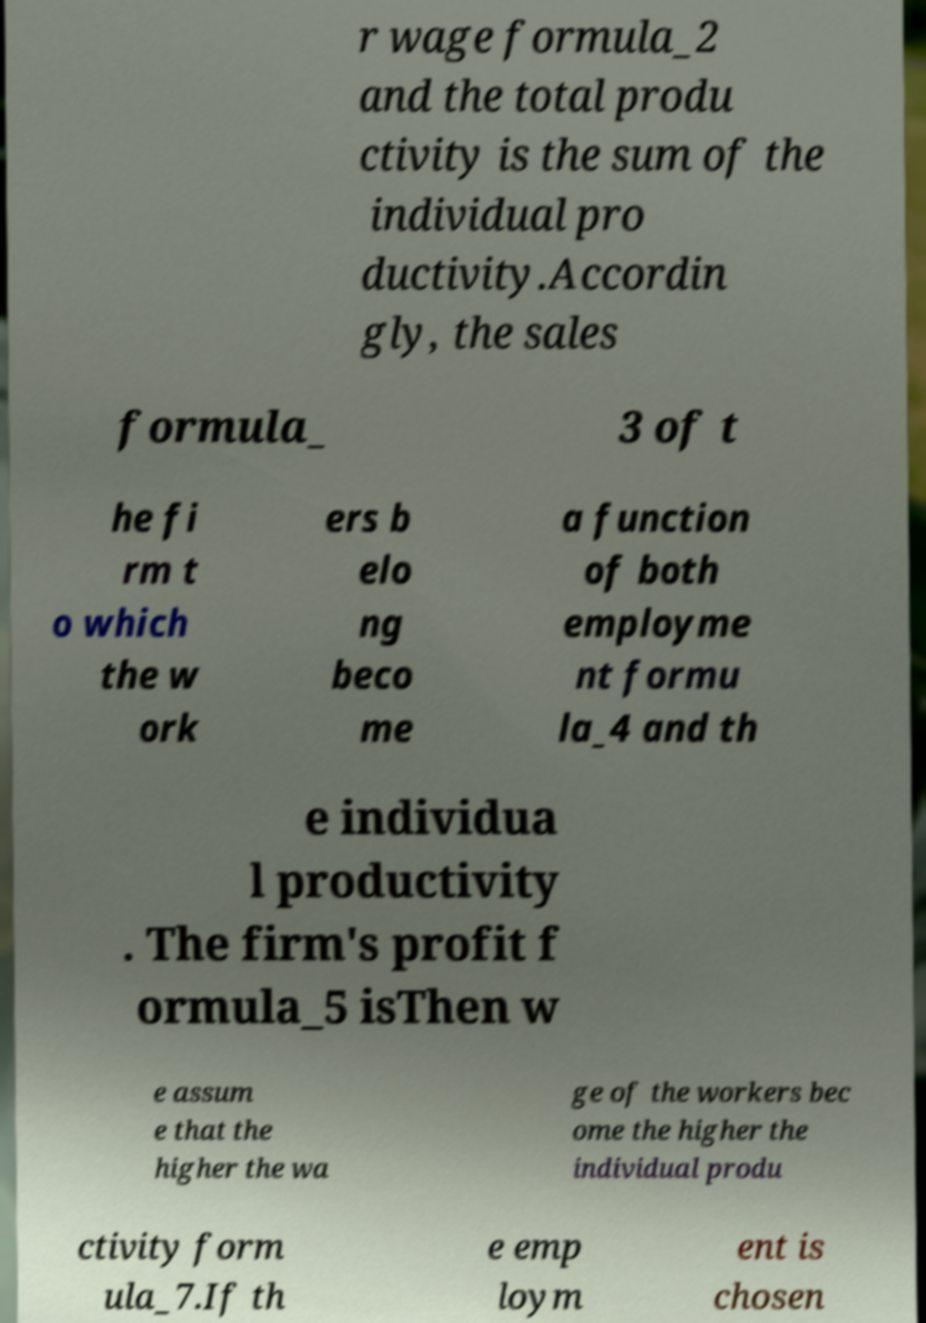For documentation purposes, I need the text within this image transcribed. Could you provide that? r wage formula_2 and the total produ ctivity is the sum of the individual pro ductivity.Accordin gly, the sales formula_ 3 of t he fi rm t o which the w ork ers b elo ng beco me a function of both employme nt formu la_4 and th e individua l productivity . The firm's profit f ormula_5 isThen w e assum e that the higher the wa ge of the workers bec ome the higher the individual produ ctivity form ula_7.If th e emp loym ent is chosen 